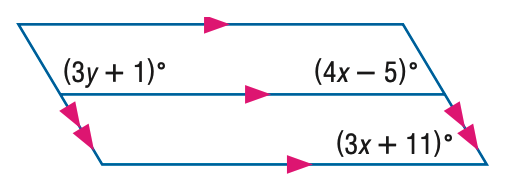Question: Find x in the figure.
Choices:
A. 14
B. 15
C. 16
D. 17
Answer with the letter. Answer: C 